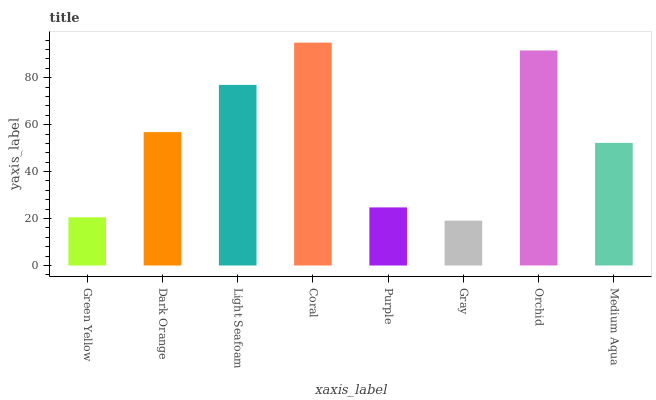Is Gray the minimum?
Answer yes or no. Yes. Is Coral the maximum?
Answer yes or no. Yes. Is Dark Orange the minimum?
Answer yes or no. No. Is Dark Orange the maximum?
Answer yes or no. No. Is Dark Orange greater than Green Yellow?
Answer yes or no. Yes. Is Green Yellow less than Dark Orange?
Answer yes or no. Yes. Is Green Yellow greater than Dark Orange?
Answer yes or no. No. Is Dark Orange less than Green Yellow?
Answer yes or no. No. Is Dark Orange the high median?
Answer yes or no. Yes. Is Medium Aqua the low median?
Answer yes or no. Yes. Is Gray the high median?
Answer yes or no. No. Is Gray the low median?
Answer yes or no. No. 